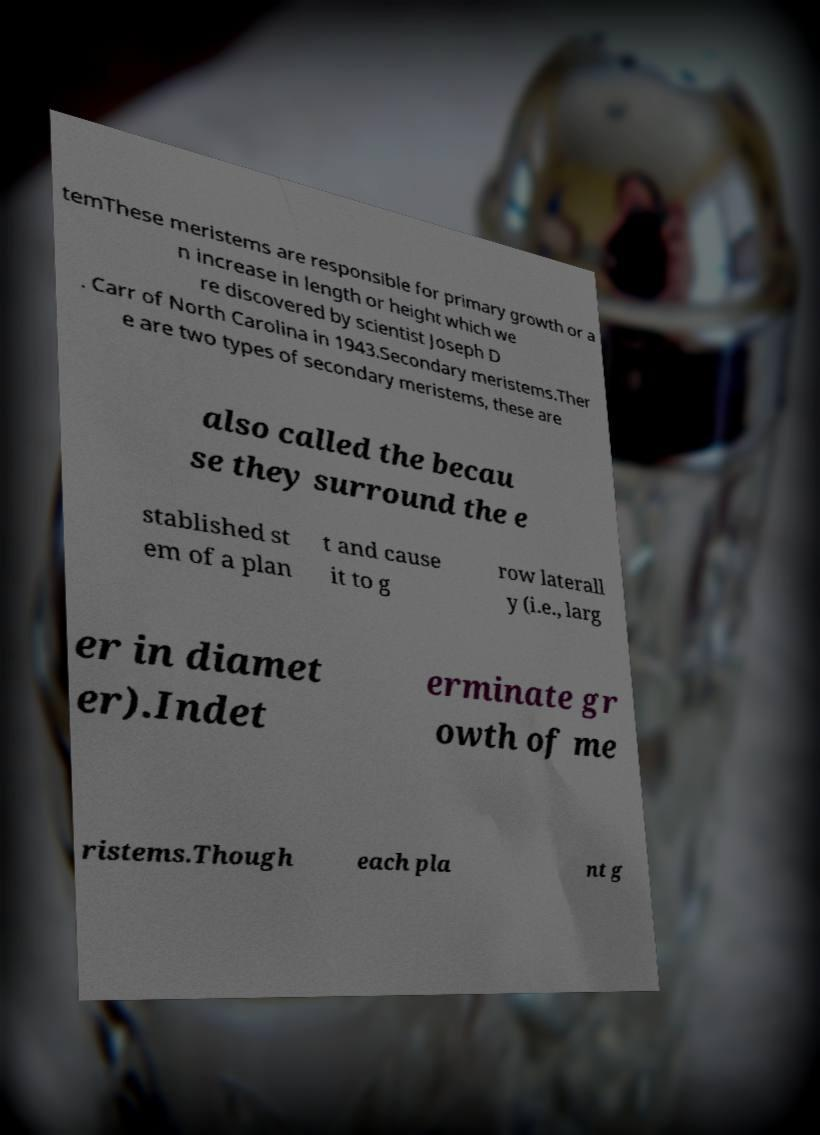Please read and relay the text visible in this image. What does it say? temThese meristems are responsible for primary growth or a n increase in length or height which we re discovered by scientist Joseph D . Carr of North Carolina in 1943.Secondary meristems.Ther e are two types of secondary meristems, these are also called the becau se they surround the e stablished st em of a plan t and cause it to g row laterall y (i.e., larg er in diamet er).Indet erminate gr owth of me ristems.Though each pla nt g 